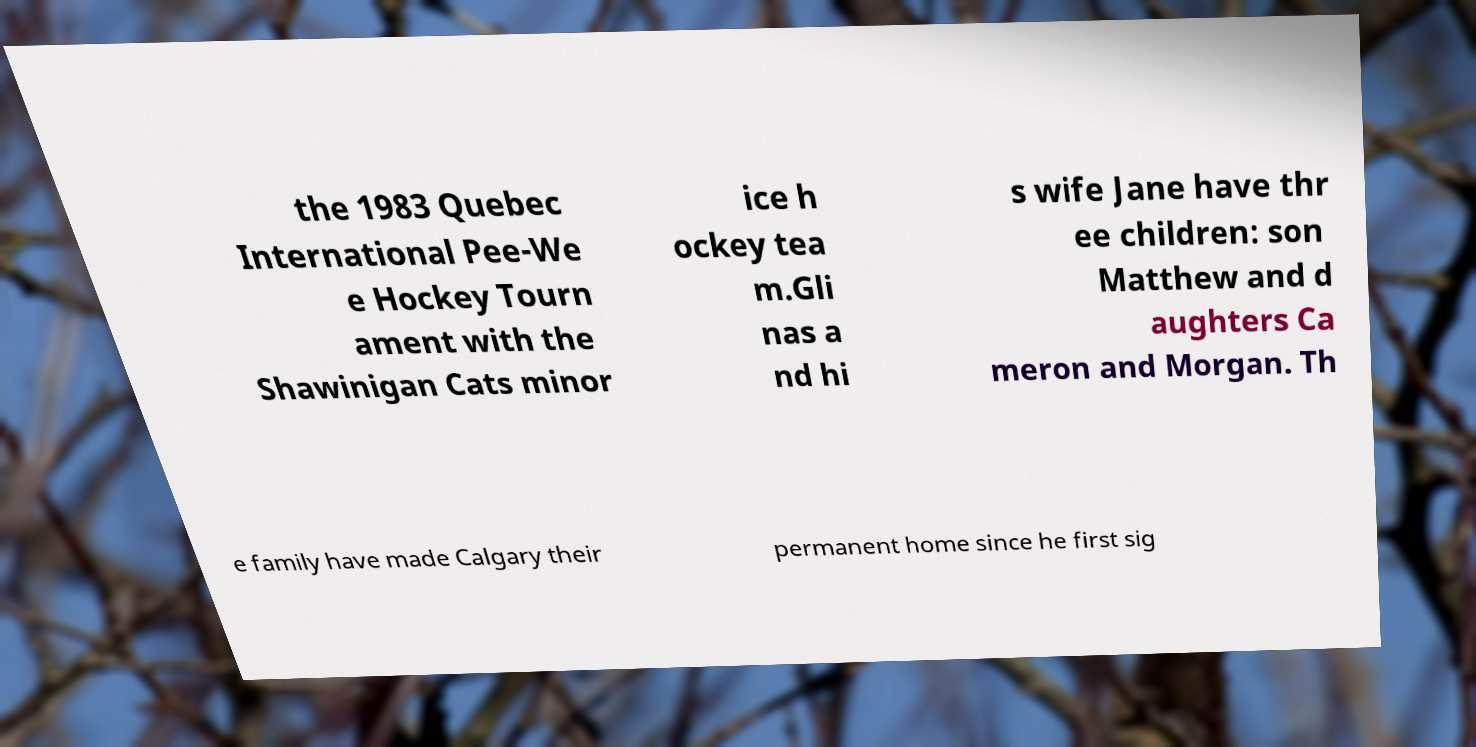Please identify and transcribe the text found in this image. the 1983 Quebec International Pee-We e Hockey Tourn ament with the Shawinigan Cats minor ice h ockey tea m.Gli nas a nd hi s wife Jane have thr ee children: son Matthew and d aughters Ca meron and Morgan. Th e family have made Calgary their permanent home since he first sig 